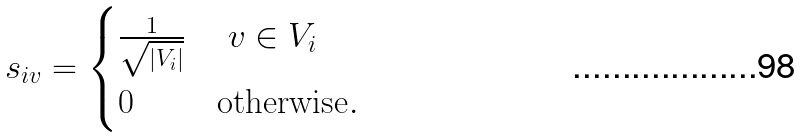Convert formula to latex. <formula><loc_0><loc_0><loc_500><loc_500>s _ { i v } = \begin{cases} \frac { 1 } { \sqrt { | V _ { i } | } } & \text { $v \in V_{i}$} \\ 0 & \text {otherwise} . \end{cases}</formula> 